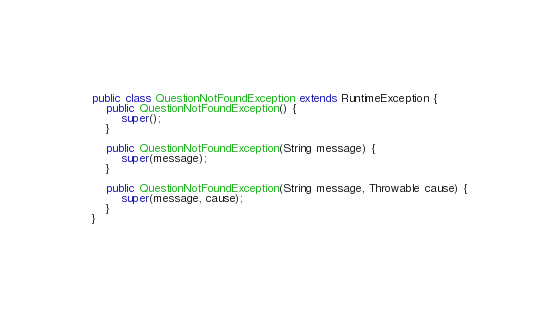Convert code to text. <code><loc_0><loc_0><loc_500><loc_500><_Java_>public class QuestionNotFoundException extends RuntimeException {
    public QuestionNotFoundException() {
        super();
    }

    public QuestionNotFoundException(String message) {
        super(message);
    }

    public QuestionNotFoundException(String message, Throwable cause) {
        super(message, cause);
    }
}
</code> 